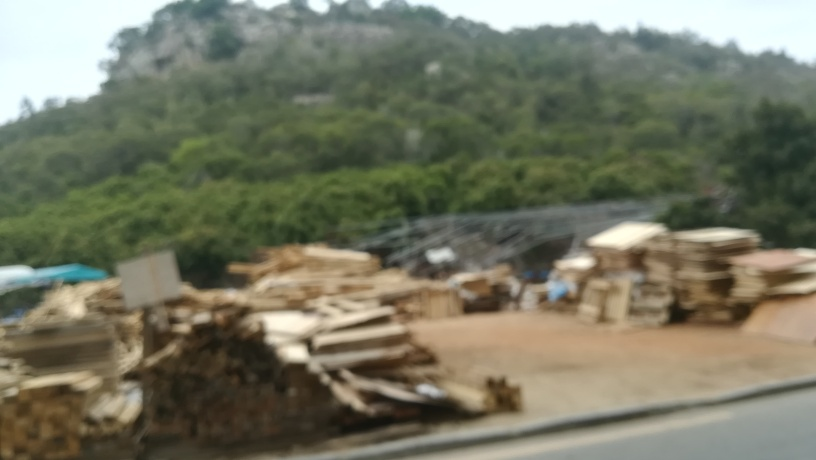What do you think is the main subject of this picture? While it's challenging to identify the main subject due to the motion blur, the prominent stacks of material in the foreground, possibly wood, seem to be a focal point of the image. How does the blurriness affect the interpretation of this image? The blurriness greatly affects the interpretation by obscuring details. It creates an impressionistic view where viewers have to rely more on general shapes and colors to form an understanding, rather than on clear, sharp details. 